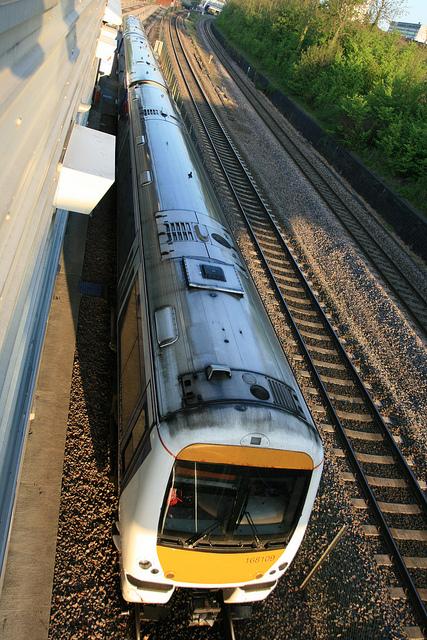Where is the train in the pic?
Be succinct. Tracks. What vehicle is this?
Keep it brief. Train. What color is this train?
Keep it brief. Silver. 